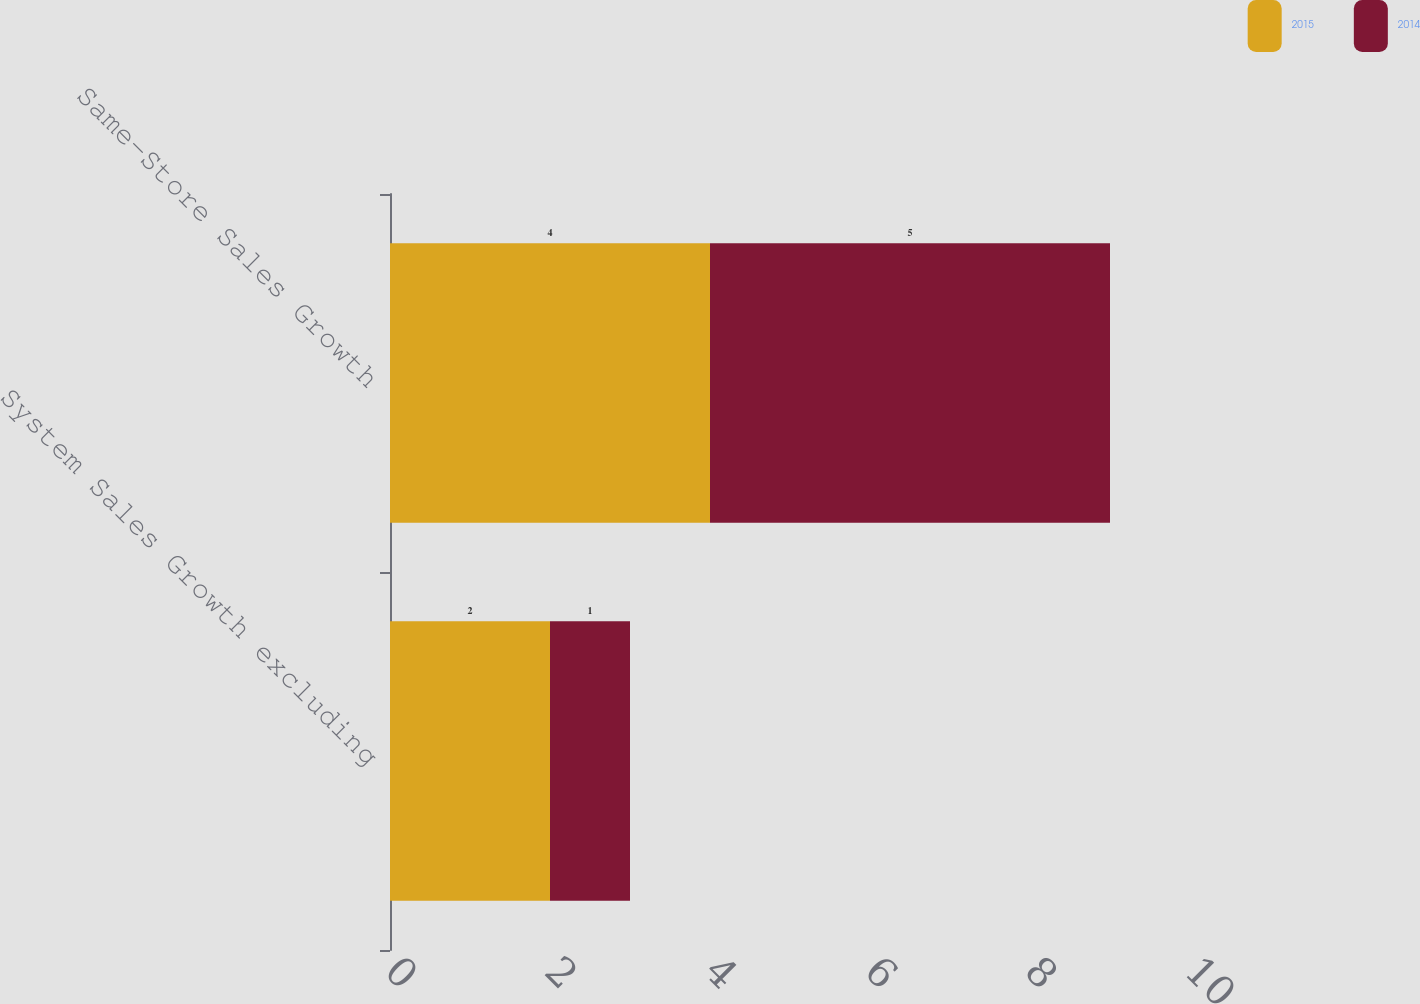Convert chart to OTSL. <chart><loc_0><loc_0><loc_500><loc_500><stacked_bar_chart><ecel><fcel>System Sales Growth excluding<fcel>Same-Store Sales Growth<nl><fcel>2015<fcel>2<fcel>4<nl><fcel>2014<fcel>1<fcel>5<nl></chart> 